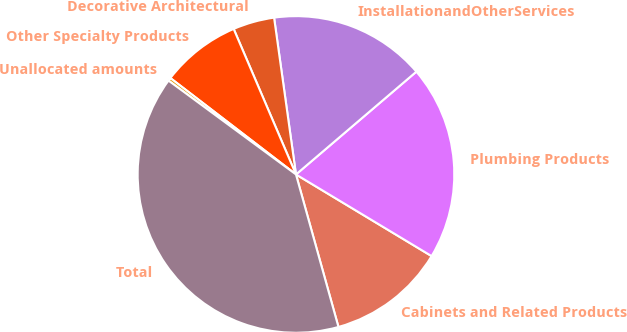Convert chart to OTSL. <chart><loc_0><loc_0><loc_500><loc_500><pie_chart><fcel>Cabinets and Related Products<fcel>Plumbing Products<fcel>InstallationandOtherServices<fcel>Decorative Architectural<fcel>Other Specialty Products<fcel>Unallocated amounts<fcel>Total<nl><fcel>12.05%<fcel>19.87%<fcel>15.96%<fcel>4.23%<fcel>8.14%<fcel>0.32%<fcel>39.42%<nl></chart> 